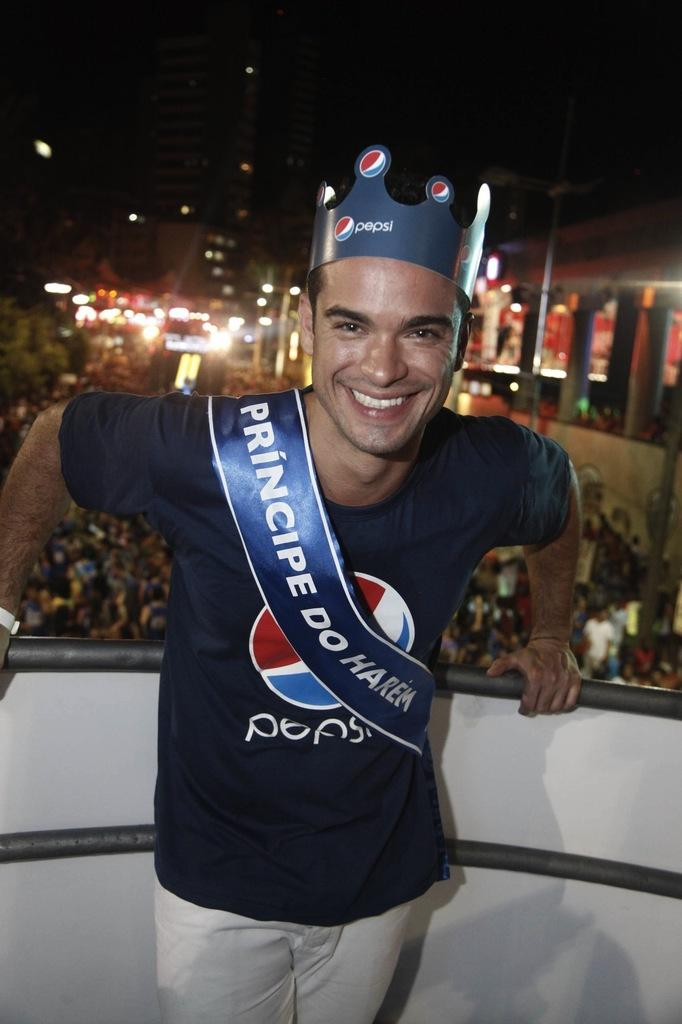<image>
Render a clear and concise summary of the photo. The gentleman in Pepsi attire looks very happy with himself. 